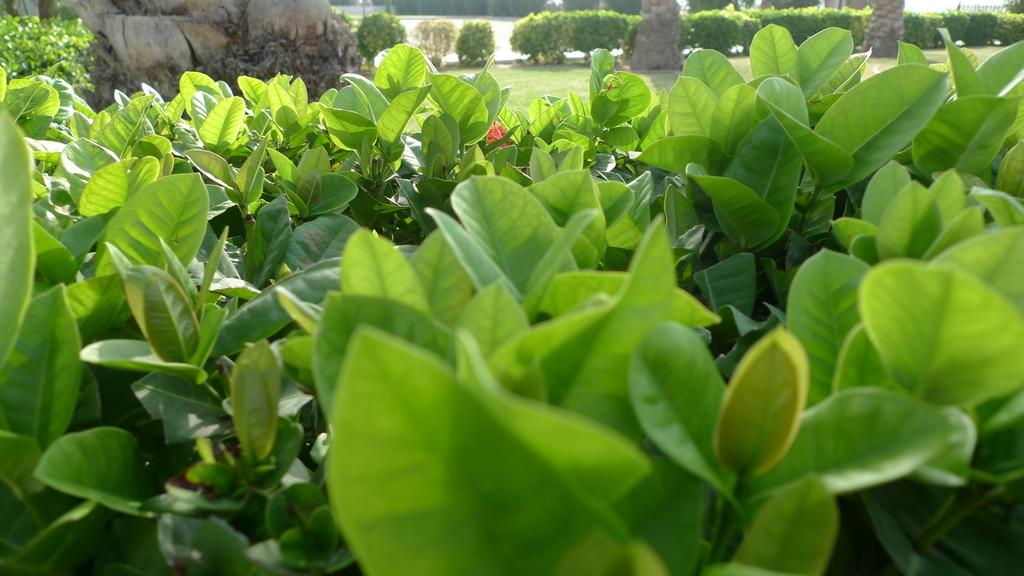What type of vegetation can be seen in the image? There are green leaves in the image. What can be seen in the background of the image? There are bushes, green grass, and trees in the background of the image. What type of wound can be seen on the branch in the image? There is no branch or wound present in the image. 